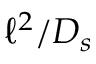Convert formula to latex. <formula><loc_0><loc_0><loc_500><loc_500>\ell ^ { 2 } / D _ { s }</formula> 